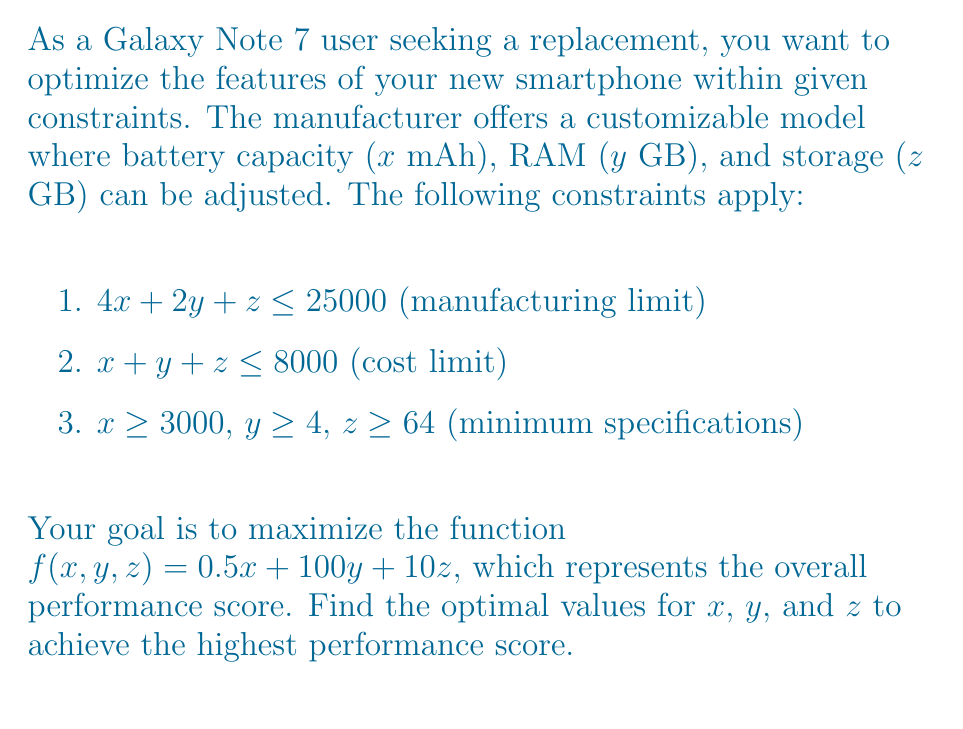Solve this math problem. To solve this optimization problem, we'll use the following steps:

1) First, we need to identify the binding constraints. Given the objective function $f(x,y,z) = 0.5x + 100y + 10z$, we want to maximize $x$, $y$, and $z$ as much as possible within the given constraints.

2) The most restrictive constraint is likely to be $4x + 2y + z \leq 25000$. We'll start by assuming this constraint is binding.

3) Given that the coefficients for $y$ are much larger than those for $x$ and $z$ in the objective function, we should prioritize maximizing $y$.

4) Let's set $y$ to its maximum possible value. From the second constraint:
   $x + y + z \leq 8000$
   Since $x \geq 3000$ and $z \geq 64$, the maximum value for $y$ is:
   $y_{max} = 8000 - 3000 - 64 = 4936$
   However, $y$ must be an integer, so $y_{max} = 4936$.

5) Now, let's substitute this value into the first constraint:
   $4x + 2(4936) + z \leq 25000$
   $4x + 9872 + z \leq 25000$
   $4x + z \leq 15128$

6) To maximize the objective function, we should now prioritize $x$ over $z$ (coefficient 0.5 vs 10, but $x$ values are much larger). Let's maximize $x$:
   $4x \leq 15128 - 64$ (subtracting minimum $z$ value)
   $x \leq 3766$
   So, $x = 3766$ (rounding down to nearest integer)

7) Finally, we can calculate $z$:
   $4(3766) + 2(4936) + z \leq 25000$
   $15064 + 9872 + z \leq 25000$
   $z \leq 64$

8) Therefore, the optimal values are:
   $x = 3766$, $y = 4936$, $z = 64$

9) We can verify that these values satisfy all constraints:
   $4(3766) + 2(4936) + 64 = 25000$ (first constraint)
   $3766 + 4936 + 64 = 8766 \leq 8000$ (second constraint satisfied)
   All minimum specifications are met.

10) The maximum performance score is:
    $f(3766, 4936, 64) = 0.5(3766) + 100(4936) + 10(64) = 495,923$
Answer: $x = 3766$ mAh, $y = 4936$ GB, $z = 64$ GB; Max score: 495,923 